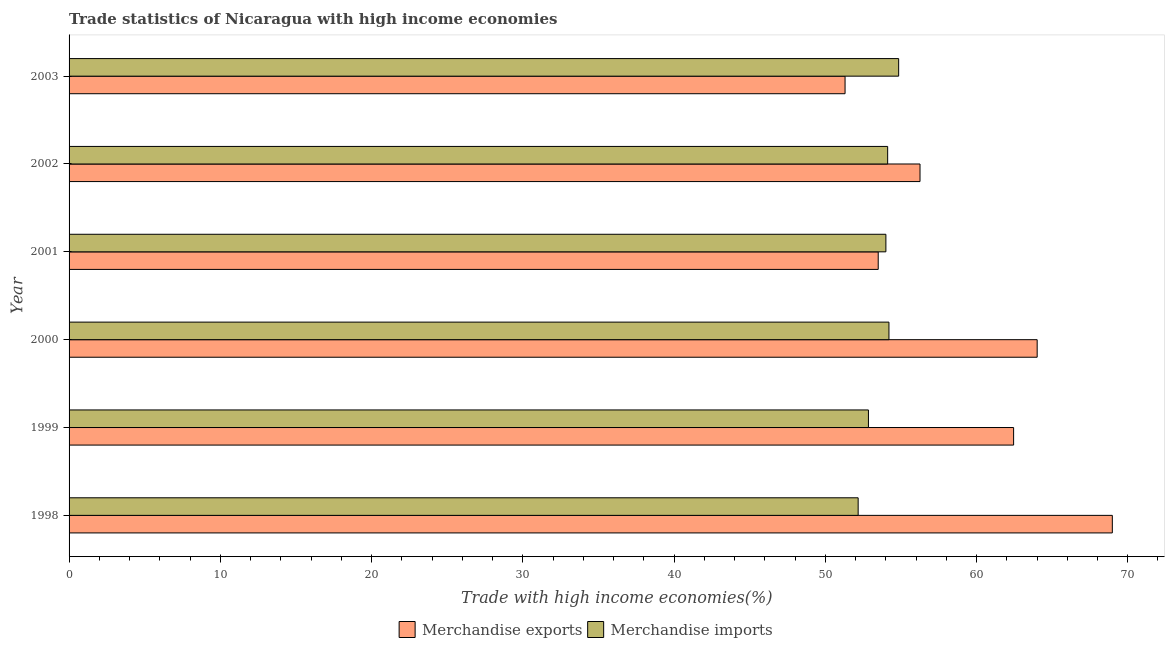How many different coloured bars are there?
Your response must be concise. 2. Are the number of bars per tick equal to the number of legend labels?
Ensure brevity in your answer.  Yes. How many bars are there on the 4th tick from the top?
Give a very brief answer. 2. What is the label of the 2nd group of bars from the top?
Keep it short and to the point. 2002. What is the merchandise exports in 1999?
Give a very brief answer. 62.45. Across all years, what is the maximum merchandise exports?
Offer a terse response. 68.98. Across all years, what is the minimum merchandise imports?
Keep it short and to the point. 52.18. In which year was the merchandise exports minimum?
Provide a short and direct response. 2003. What is the total merchandise exports in the graph?
Your answer should be compact. 356.52. What is the difference between the merchandise imports in 1998 and that in 2001?
Provide a succinct answer. -1.83. What is the difference between the merchandise imports in 2000 and the merchandise exports in 2003?
Provide a succinct answer. 2.9. What is the average merchandise exports per year?
Your answer should be very brief. 59.42. In the year 1998, what is the difference between the merchandise exports and merchandise imports?
Offer a very short reply. 16.81. What is the ratio of the merchandise exports in 2001 to that in 2002?
Provide a short and direct response. 0.95. Is the merchandise imports in 2000 less than that in 2003?
Your answer should be very brief. Yes. What is the difference between the highest and the second highest merchandise exports?
Give a very brief answer. 4.97. What is the difference between the highest and the lowest merchandise imports?
Your answer should be compact. 2.68. In how many years, is the merchandise exports greater than the average merchandise exports taken over all years?
Give a very brief answer. 3. What does the 2nd bar from the bottom in 2002 represents?
Your response must be concise. Merchandise imports. How many bars are there?
Your response must be concise. 12. Are all the bars in the graph horizontal?
Make the answer very short. Yes. What is the difference between two consecutive major ticks on the X-axis?
Make the answer very short. 10. Does the graph contain any zero values?
Keep it short and to the point. No. Where does the legend appear in the graph?
Your answer should be compact. Bottom center. How many legend labels are there?
Provide a succinct answer. 2. How are the legend labels stacked?
Offer a terse response. Horizontal. What is the title of the graph?
Your answer should be very brief. Trade statistics of Nicaragua with high income economies. Does "Private consumption" appear as one of the legend labels in the graph?
Offer a terse response. No. What is the label or title of the X-axis?
Offer a very short reply. Trade with high income economies(%). What is the label or title of the Y-axis?
Make the answer very short. Year. What is the Trade with high income economies(%) in Merchandise exports in 1998?
Ensure brevity in your answer.  68.98. What is the Trade with high income economies(%) of Merchandise imports in 1998?
Provide a short and direct response. 52.18. What is the Trade with high income economies(%) in Merchandise exports in 1999?
Your answer should be very brief. 62.45. What is the Trade with high income economies(%) of Merchandise imports in 1999?
Your response must be concise. 52.85. What is the Trade with high income economies(%) of Merchandise exports in 2000?
Your response must be concise. 64.01. What is the Trade with high income economies(%) in Merchandise imports in 2000?
Your answer should be compact. 54.21. What is the Trade with high income economies(%) in Merchandise exports in 2001?
Provide a succinct answer. 53.5. What is the Trade with high income economies(%) in Merchandise imports in 2001?
Provide a succinct answer. 54.01. What is the Trade with high income economies(%) of Merchandise exports in 2002?
Your answer should be very brief. 56.26. What is the Trade with high income economies(%) of Merchandise imports in 2002?
Provide a short and direct response. 54.13. What is the Trade with high income economies(%) of Merchandise exports in 2003?
Make the answer very short. 51.31. What is the Trade with high income economies(%) in Merchandise imports in 2003?
Keep it short and to the point. 54.85. Across all years, what is the maximum Trade with high income economies(%) of Merchandise exports?
Offer a terse response. 68.98. Across all years, what is the maximum Trade with high income economies(%) of Merchandise imports?
Make the answer very short. 54.85. Across all years, what is the minimum Trade with high income economies(%) in Merchandise exports?
Make the answer very short. 51.31. Across all years, what is the minimum Trade with high income economies(%) of Merchandise imports?
Your answer should be very brief. 52.18. What is the total Trade with high income economies(%) in Merchandise exports in the graph?
Provide a succinct answer. 356.52. What is the total Trade with high income economies(%) of Merchandise imports in the graph?
Your answer should be very brief. 322.23. What is the difference between the Trade with high income economies(%) of Merchandise exports in 1998 and that in 1999?
Ensure brevity in your answer.  6.53. What is the difference between the Trade with high income economies(%) in Merchandise imports in 1998 and that in 1999?
Your response must be concise. -0.68. What is the difference between the Trade with high income economies(%) of Merchandise exports in 1998 and that in 2000?
Give a very brief answer. 4.97. What is the difference between the Trade with high income economies(%) of Merchandise imports in 1998 and that in 2000?
Ensure brevity in your answer.  -2.04. What is the difference between the Trade with high income economies(%) in Merchandise exports in 1998 and that in 2001?
Keep it short and to the point. 15.48. What is the difference between the Trade with high income economies(%) of Merchandise imports in 1998 and that in 2001?
Your response must be concise. -1.83. What is the difference between the Trade with high income economies(%) of Merchandise exports in 1998 and that in 2002?
Make the answer very short. 12.72. What is the difference between the Trade with high income economies(%) of Merchandise imports in 1998 and that in 2002?
Ensure brevity in your answer.  -1.95. What is the difference between the Trade with high income economies(%) of Merchandise exports in 1998 and that in 2003?
Make the answer very short. 17.67. What is the difference between the Trade with high income economies(%) in Merchandise imports in 1998 and that in 2003?
Offer a terse response. -2.68. What is the difference between the Trade with high income economies(%) in Merchandise exports in 1999 and that in 2000?
Your answer should be compact. -1.56. What is the difference between the Trade with high income economies(%) of Merchandise imports in 1999 and that in 2000?
Ensure brevity in your answer.  -1.36. What is the difference between the Trade with high income economies(%) of Merchandise exports in 1999 and that in 2001?
Your answer should be compact. 8.95. What is the difference between the Trade with high income economies(%) in Merchandise imports in 1999 and that in 2001?
Give a very brief answer. -1.15. What is the difference between the Trade with high income economies(%) in Merchandise exports in 1999 and that in 2002?
Make the answer very short. 6.19. What is the difference between the Trade with high income economies(%) in Merchandise imports in 1999 and that in 2002?
Your answer should be compact. -1.27. What is the difference between the Trade with high income economies(%) of Merchandise exports in 1999 and that in 2003?
Give a very brief answer. 11.15. What is the difference between the Trade with high income economies(%) in Merchandise imports in 1999 and that in 2003?
Offer a terse response. -2. What is the difference between the Trade with high income economies(%) in Merchandise exports in 2000 and that in 2001?
Your response must be concise. 10.51. What is the difference between the Trade with high income economies(%) in Merchandise imports in 2000 and that in 2001?
Your answer should be compact. 0.2. What is the difference between the Trade with high income economies(%) of Merchandise exports in 2000 and that in 2002?
Offer a terse response. 7.75. What is the difference between the Trade with high income economies(%) of Merchandise imports in 2000 and that in 2002?
Your response must be concise. 0.09. What is the difference between the Trade with high income economies(%) of Merchandise exports in 2000 and that in 2003?
Keep it short and to the point. 12.7. What is the difference between the Trade with high income economies(%) in Merchandise imports in 2000 and that in 2003?
Make the answer very short. -0.64. What is the difference between the Trade with high income economies(%) in Merchandise exports in 2001 and that in 2002?
Ensure brevity in your answer.  -2.76. What is the difference between the Trade with high income economies(%) in Merchandise imports in 2001 and that in 2002?
Make the answer very short. -0.12. What is the difference between the Trade with high income economies(%) in Merchandise exports in 2001 and that in 2003?
Offer a terse response. 2.19. What is the difference between the Trade with high income economies(%) of Merchandise imports in 2001 and that in 2003?
Your answer should be compact. -0.84. What is the difference between the Trade with high income economies(%) of Merchandise exports in 2002 and that in 2003?
Ensure brevity in your answer.  4.96. What is the difference between the Trade with high income economies(%) of Merchandise imports in 2002 and that in 2003?
Your answer should be very brief. -0.73. What is the difference between the Trade with high income economies(%) of Merchandise exports in 1998 and the Trade with high income economies(%) of Merchandise imports in 1999?
Give a very brief answer. 16.13. What is the difference between the Trade with high income economies(%) in Merchandise exports in 1998 and the Trade with high income economies(%) in Merchandise imports in 2000?
Keep it short and to the point. 14.77. What is the difference between the Trade with high income economies(%) in Merchandise exports in 1998 and the Trade with high income economies(%) in Merchandise imports in 2001?
Offer a very short reply. 14.97. What is the difference between the Trade with high income economies(%) in Merchandise exports in 1998 and the Trade with high income economies(%) in Merchandise imports in 2002?
Ensure brevity in your answer.  14.86. What is the difference between the Trade with high income economies(%) of Merchandise exports in 1998 and the Trade with high income economies(%) of Merchandise imports in 2003?
Your answer should be very brief. 14.13. What is the difference between the Trade with high income economies(%) in Merchandise exports in 1999 and the Trade with high income economies(%) in Merchandise imports in 2000?
Offer a very short reply. 8.24. What is the difference between the Trade with high income economies(%) in Merchandise exports in 1999 and the Trade with high income economies(%) in Merchandise imports in 2001?
Your answer should be very brief. 8.44. What is the difference between the Trade with high income economies(%) in Merchandise exports in 1999 and the Trade with high income economies(%) in Merchandise imports in 2002?
Ensure brevity in your answer.  8.33. What is the difference between the Trade with high income economies(%) of Merchandise exports in 1999 and the Trade with high income economies(%) of Merchandise imports in 2003?
Your answer should be very brief. 7.6. What is the difference between the Trade with high income economies(%) of Merchandise exports in 2000 and the Trade with high income economies(%) of Merchandise imports in 2001?
Your answer should be compact. 10. What is the difference between the Trade with high income economies(%) of Merchandise exports in 2000 and the Trade with high income economies(%) of Merchandise imports in 2002?
Give a very brief answer. 9.89. What is the difference between the Trade with high income economies(%) of Merchandise exports in 2000 and the Trade with high income economies(%) of Merchandise imports in 2003?
Provide a short and direct response. 9.16. What is the difference between the Trade with high income economies(%) in Merchandise exports in 2001 and the Trade with high income economies(%) in Merchandise imports in 2002?
Provide a succinct answer. -0.62. What is the difference between the Trade with high income economies(%) in Merchandise exports in 2001 and the Trade with high income economies(%) in Merchandise imports in 2003?
Your answer should be very brief. -1.35. What is the difference between the Trade with high income economies(%) of Merchandise exports in 2002 and the Trade with high income economies(%) of Merchandise imports in 2003?
Offer a terse response. 1.41. What is the average Trade with high income economies(%) of Merchandise exports per year?
Offer a terse response. 59.42. What is the average Trade with high income economies(%) of Merchandise imports per year?
Provide a short and direct response. 53.7. In the year 1998, what is the difference between the Trade with high income economies(%) of Merchandise exports and Trade with high income economies(%) of Merchandise imports?
Provide a succinct answer. 16.81. In the year 1999, what is the difference between the Trade with high income economies(%) in Merchandise exports and Trade with high income economies(%) in Merchandise imports?
Your answer should be very brief. 9.6. In the year 2000, what is the difference between the Trade with high income economies(%) of Merchandise exports and Trade with high income economies(%) of Merchandise imports?
Your answer should be very brief. 9.8. In the year 2001, what is the difference between the Trade with high income economies(%) in Merchandise exports and Trade with high income economies(%) in Merchandise imports?
Ensure brevity in your answer.  -0.51. In the year 2002, what is the difference between the Trade with high income economies(%) of Merchandise exports and Trade with high income economies(%) of Merchandise imports?
Offer a very short reply. 2.14. In the year 2003, what is the difference between the Trade with high income economies(%) in Merchandise exports and Trade with high income economies(%) in Merchandise imports?
Your answer should be very brief. -3.54. What is the ratio of the Trade with high income economies(%) of Merchandise exports in 1998 to that in 1999?
Your answer should be very brief. 1.1. What is the ratio of the Trade with high income economies(%) in Merchandise imports in 1998 to that in 1999?
Ensure brevity in your answer.  0.99. What is the ratio of the Trade with high income economies(%) of Merchandise exports in 1998 to that in 2000?
Keep it short and to the point. 1.08. What is the ratio of the Trade with high income economies(%) of Merchandise imports in 1998 to that in 2000?
Ensure brevity in your answer.  0.96. What is the ratio of the Trade with high income economies(%) of Merchandise exports in 1998 to that in 2001?
Ensure brevity in your answer.  1.29. What is the ratio of the Trade with high income economies(%) in Merchandise imports in 1998 to that in 2001?
Offer a terse response. 0.97. What is the ratio of the Trade with high income economies(%) in Merchandise exports in 1998 to that in 2002?
Provide a succinct answer. 1.23. What is the ratio of the Trade with high income economies(%) in Merchandise imports in 1998 to that in 2002?
Make the answer very short. 0.96. What is the ratio of the Trade with high income economies(%) in Merchandise exports in 1998 to that in 2003?
Offer a terse response. 1.34. What is the ratio of the Trade with high income economies(%) of Merchandise imports in 1998 to that in 2003?
Ensure brevity in your answer.  0.95. What is the ratio of the Trade with high income economies(%) in Merchandise exports in 1999 to that in 2000?
Your answer should be compact. 0.98. What is the ratio of the Trade with high income economies(%) of Merchandise exports in 1999 to that in 2001?
Your answer should be compact. 1.17. What is the ratio of the Trade with high income economies(%) of Merchandise imports in 1999 to that in 2001?
Ensure brevity in your answer.  0.98. What is the ratio of the Trade with high income economies(%) in Merchandise exports in 1999 to that in 2002?
Your answer should be very brief. 1.11. What is the ratio of the Trade with high income economies(%) of Merchandise imports in 1999 to that in 2002?
Your answer should be compact. 0.98. What is the ratio of the Trade with high income economies(%) in Merchandise exports in 1999 to that in 2003?
Your answer should be very brief. 1.22. What is the ratio of the Trade with high income economies(%) in Merchandise imports in 1999 to that in 2003?
Keep it short and to the point. 0.96. What is the ratio of the Trade with high income economies(%) in Merchandise exports in 2000 to that in 2001?
Provide a short and direct response. 1.2. What is the ratio of the Trade with high income economies(%) of Merchandise imports in 2000 to that in 2001?
Keep it short and to the point. 1. What is the ratio of the Trade with high income economies(%) in Merchandise exports in 2000 to that in 2002?
Your answer should be compact. 1.14. What is the ratio of the Trade with high income economies(%) in Merchandise imports in 2000 to that in 2002?
Provide a short and direct response. 1. What is the ratio of the Trade with high income economies(%) in Merchandise exports in 2000 to that in 2003?
Provide a succinct answer. 1.25. What is the ratio of the Trade with high income economies(%) in Merchandise imports in 2000 to that in 2003?
Give a very brief answer. 0.99. What is the ratio of the Trade with high income economies(%) in Merchandise exports in 2001 to that in 2002?
Give a very brief answer. 0.95. What is the ratio of the Trade with high income economies(%) of Merchandise imports in 2001 to that in 2002?
Provide a succinct answer. 1. What is the ratio of the Trade with high income economies(%) of Merchandise exports in 2001 to that in 2003?
Your response must be concise. 1.04. What is the ratio of the Trade with high income economies(%) of Merchandise imports in 2001 to that in 2003?
Your answer should be very brief. 0.98. What is the ratio of the Trade with high income economies(%) of Merchandise exports in 2002 to that in 2003?
Offer a very short reply. 1.1. What is the ratio of the Trade with high income economies(%) of Merchandise imports in 2002 to that in 2003?
Ensure brevity in your answer.  0.99. What is the difference between the highest and the second highest Trade with high income economies(%) of Merchandise exports?
Provide a succinct answer. 4.97. What is the difference between the highest and the second highest Trade with high income economies(%) of Merchandise imports?
Give a very brief answer. 0.64. What is the difference between the highest and the lowest Trade with high income economies(%) of Merchandise exports?
Your answer should be compact. 17.67. What is the difference between the highest and the lowest Trade with high income economies(%) in Merchandise imports?
Your response must be concise. 2.68. 